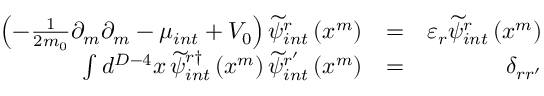Convert formula to latex. <formula><loc_0><loc_0><loc_500><loc_500>\begin{array} { r l r } { \left ( - \frac { 1 } { 2 m _ { 0 } } \partial _ { m } \partial _ { m } - \mu _ { i n t } + V _ { 0 } \right ) \widetilde { \psi } _ { i n t } ^ { r } \left ( x ^ { m } \right ) } & { = } & { \varepsilon _ { r } \widetilde { \psi } _ { i n t } ^ { r } \left ( x ^ { m } \right ) } \\ { \int d ^ { D - 4 } x \, \widetilde { \psi } _ { i n t } ^ { r \dag } \left ( x ^ { m } \right ) \widetilde { \psi } _ { i n t } ^ { r ^ { \prime } } \left ( x ^ { m } \right ) } & { = } & { \delta _ { r r ^ { \prime } } } \end{array}</formula> 